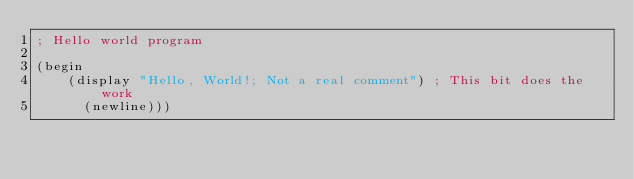<code> <loc_0><loc_0><loc_500><loc_500><_Scheme_>; Hello world program

(begin 
    (display "Hello, World!; Not a real comment") ; This bit does the work
      (newline)))
</code> 